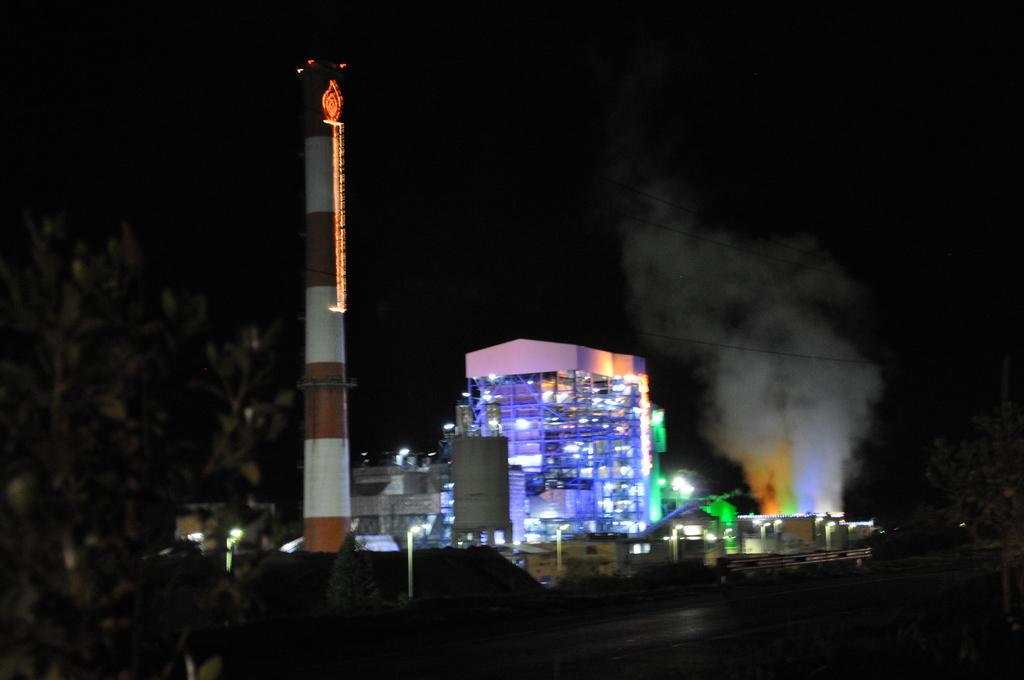What structures can be seen in the image? There are buildings in the image. Where is the tree located in the image? The tree is on the left side of the image. What can be seen illuminated in the image? There are lights visible in the image. What type of baseball game is taking place in the image? There is no baseball game present in the image. Can you hear the bells ringing in the image? There are no bells present in the image, so it is not possible to hear them ringing. 